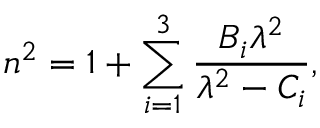<formula> <loc_0><loc_0><loc_500><loc_500>n ^ { 2 } = 1 + \sum _ { i = 1 } ^ { 3 } \frac { B _ { i } \lambda ^ { 2 } } { \lambda ^ { 2 } - C _ { i } } ,</formula> 